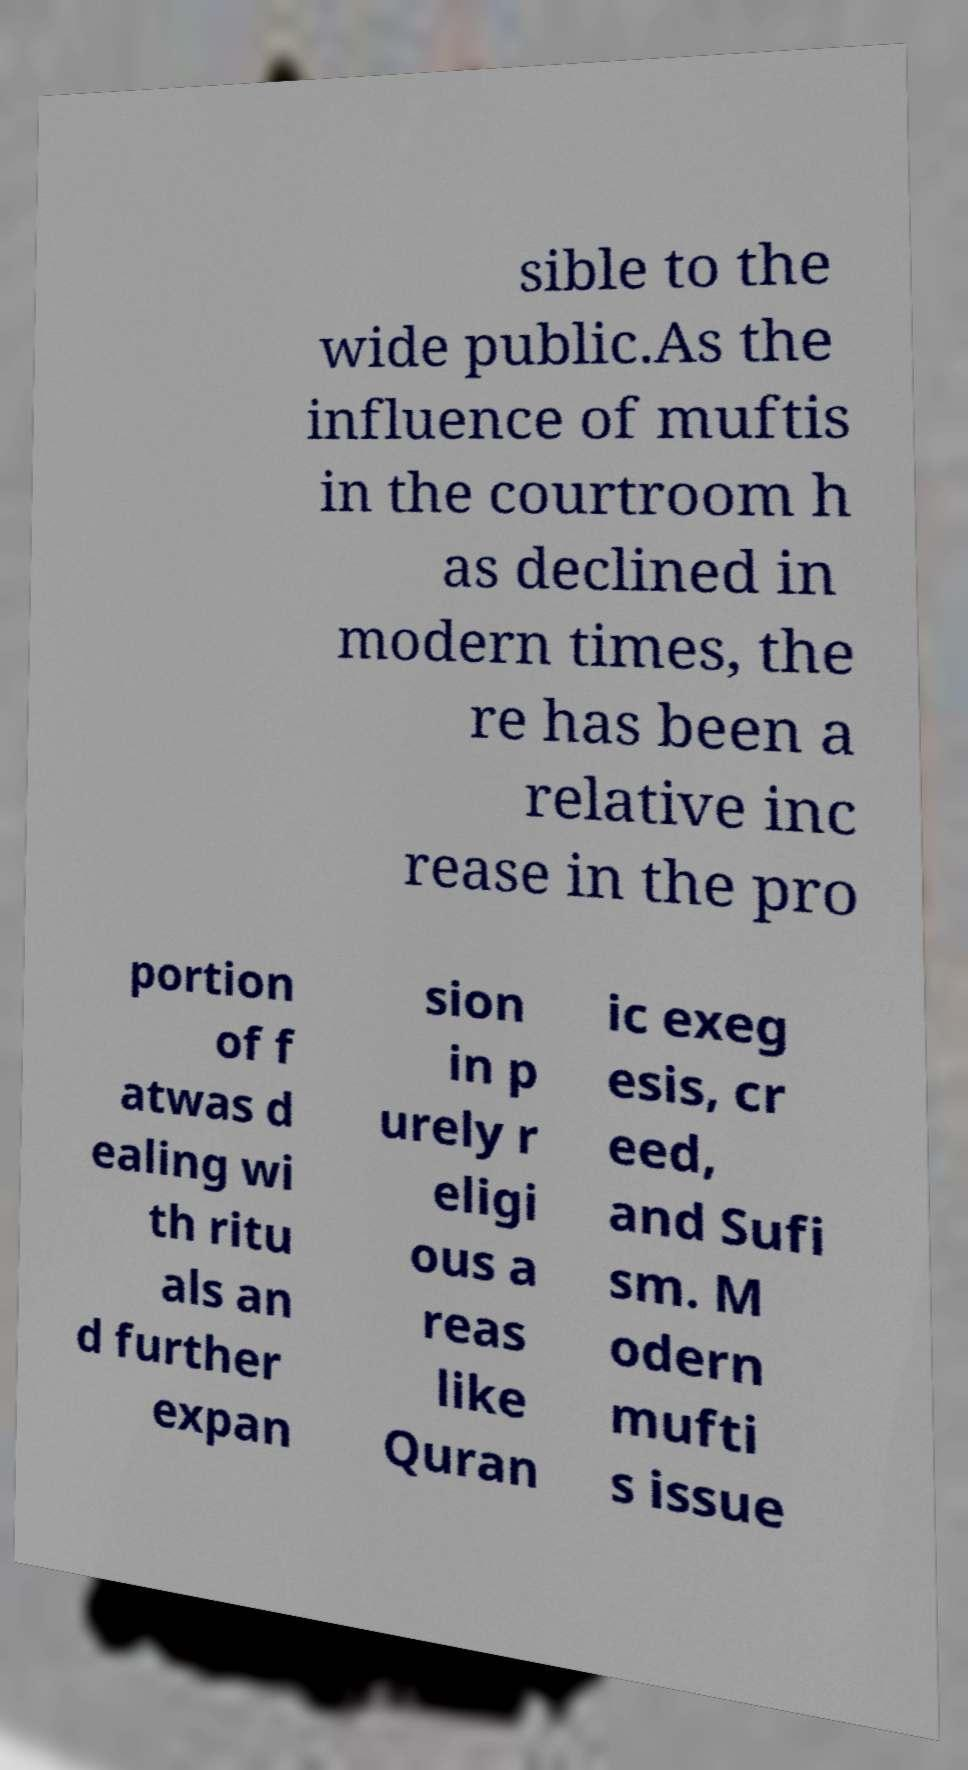For documentation purposes, I need the text within this image transcribed. Could you provide that? sible to the wide public.As the influence of muftis in the courtroom h as declined in modern times, the re has been a relative inc rease in the pro portion of f atwas d ealing wi th ritu als an d further expan sion in p urely r eligi ous a reas like Quran ic exeg esis, cr eed, and Sufi sm. M odern mufti s issue 